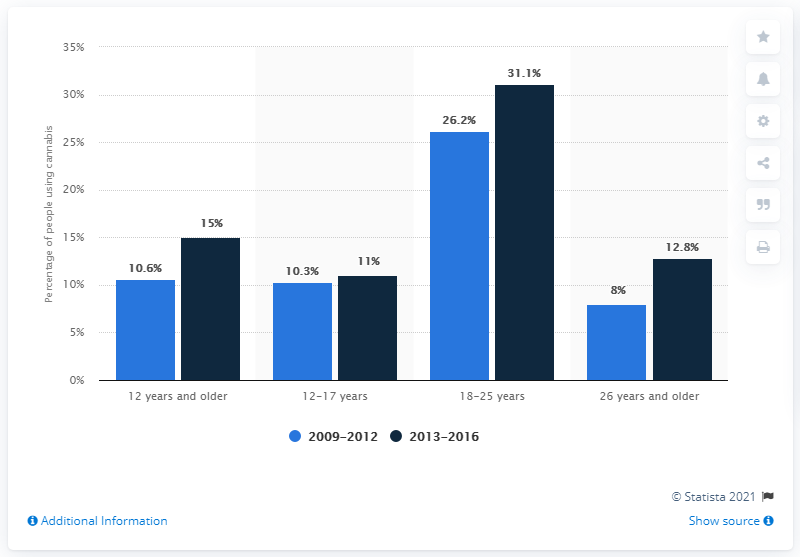Give some essential details in this illustration. Between 2009 and 2012, it is estimated that youth and young adults in Colorado had used cannabis. In 18-25 year olds, 26.2% used cannabis prior to legalization. According to the data, 31.1% of 18-25 year olds used cannabis within the past month. 